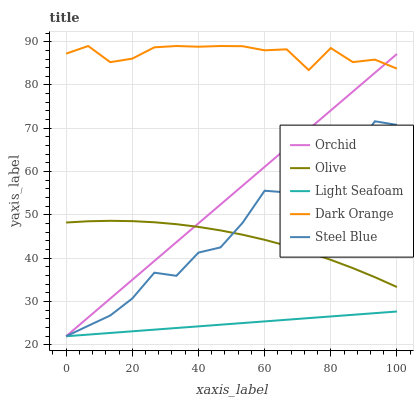Does Light Seafoam have the minimum area under the curve?
Answer yes or no. Yes. Does Dark Orange have the maximum area under the curve?
Answer yes or no. Yes. Does Dark Orange have the minimum area under the curve?
Answer yes or no. No. Does Light Seafoam have the maximum area under the curve?
Answer yes or no. No. Is Light Seafoam the smoothest?
Answer yes or no. Yes. Is Steel Blue the roughest?
Answer yes or no. Yes. Is Dark Orange the smoothest?
Answer yes or no. No. Is Dark Orange the roughest?
Answer yes or no. No. Does Light Seafoam have the lowest value?
Answer yes or no. Yes. Does Dark Orange have the lowest value?
Answer yes or no. No. Does Dark Orange have the highest value?
Answer yes or no. Yes. Does Light Seafoam have the highest value?
Answer yes or no. No. Is Light Seafoam less than Olive?
Answer yes or no. Yes. Is Dark Orange greater than Light Seafoam?
Answer yes or no. Yes. Does Steel Blue intersect Orchid?
Answer yes or no. Yes. Is Steel Blue less than Orchid?
Answer yes or no. No. Is Steel Blue greater than Orchid?
Answer yes or no. No. Does Light Seafoam intersect Olive?
Answer yes or no. No. 